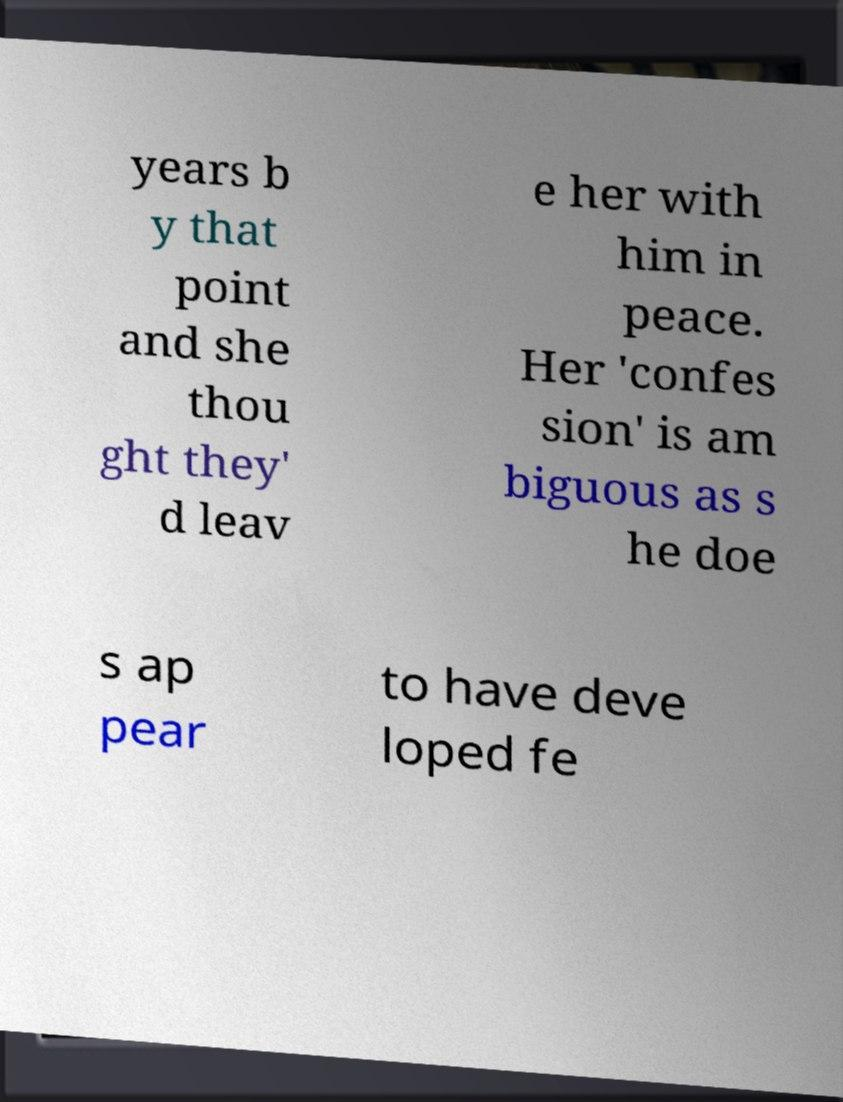Could you extract and type out the text from this image? years b y that point and she thou ght they' d leav e her with him in peace. Her 'confes sion' is am biguous as s he doe s ap pear to have deve loped fe 